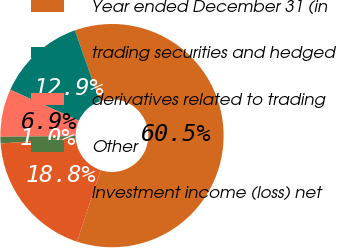<chart> <loc_0><loc_0><loc_500><loc_500><pie_chart><fcel>Year ended December 31 (in<fcel>trading securities and hedged<fcel>derivatives related to trading<fcel>Other<fcel>Investment income (loss) net<nl><fcel>60.45%<fcel>12.86%<fcel>6.91%<fcel>0.96%<fcel>18.81%<nl></chart> 